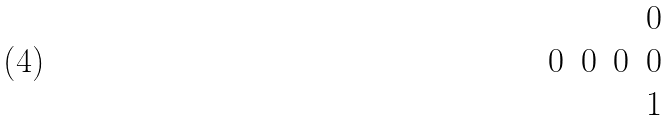<formula> <loc_0><loc_0><loc_500><loc_500>\begin{matrix} & & & 0 \\ 0 & 0 & 0 & 0 \\ & & & 1 \\ \end{matrix}</formula> 